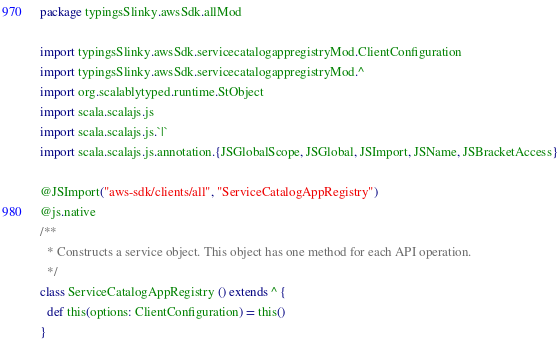Convert code to text. <code><loc_0><loc_0><loc_500><loc_500><_Scala_>package typingsSlinky.awsSdk.allMod

import typingsSlinky.awsSdk.servicecatalogappregistryMod.ClientConfiguration
import typingsSlinky.awsSdk.servicecatalogappregistryMod.^
import org.scalablytyped.runtime.StObject
import scala.scalajs.js
import scala.scalajs.js.`|`
import scala.scalajs.js.annotation.{JSGlobalScope, JSGlobal, JSImport, JSName, JSBracketAccess}

@JSImport("aws-sdk/clients/all", "ServiceCatalogAppRegistry")
@js.native
/**
  * Constructs a service object. This object has one method for each API operation.
  */
class ServiceCatalogAppRegistry () extends ^ {
  def this(options: ClientConfiguration) = this()
}
</code> 